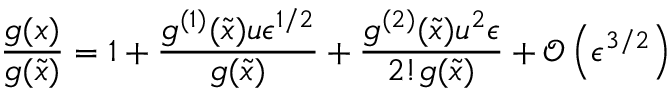Convert formula to latex. <formula><loc_0><loc_0><loc_500><loc_500>\frac { g ( x ) } { g ( \tilde { x } ) } = 1 + \frac { g ^ { ( 1 ) } ( \tilde { x } ) u \epsilon ^ { 1 / 2 } } { g ( \tilde { x } ) } + \frac { g ^ { ( 2 ) } ( \tilde { x } ) u ^ { 2 } \epsilon } { 2 ! g ( \tilde { x } ) } + \mathcal { O } \left ( \epsilon ^ { 3 / 2 } \right )</formula> 